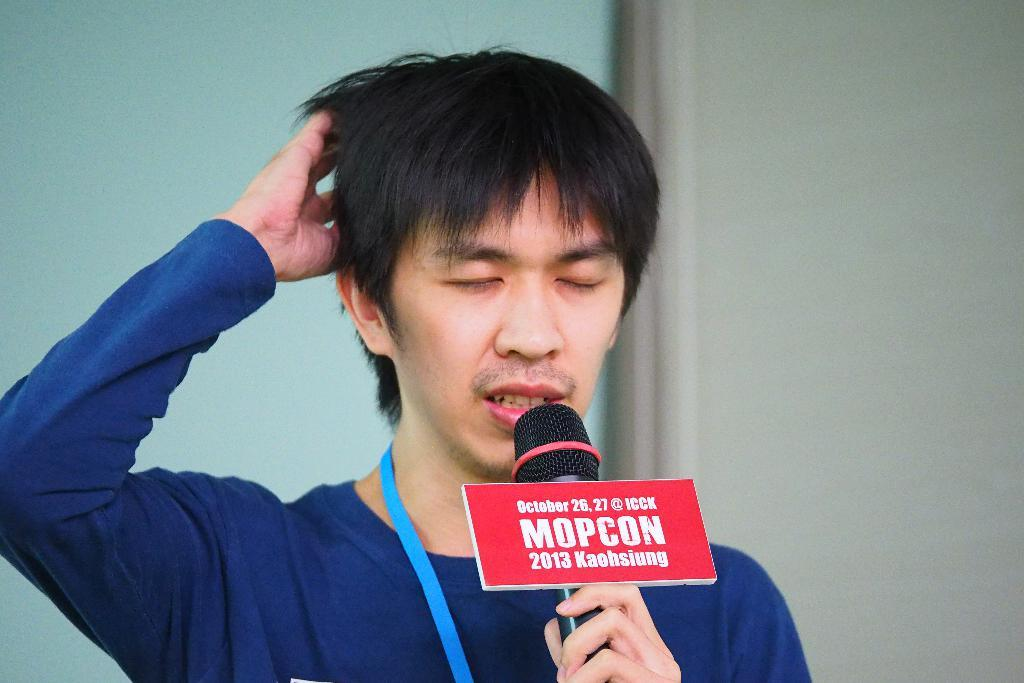What is the main subject of the image? There is a person in the image. What is the person holding in the image? The person is holding a microphone. Can you describe the object attached to the microphone? There is an aboard attached to the microphone with text on it. What can be seen in the background of the image? The background of the image is visible. What type of teeth can be seen growing on the seed in the image? There is no seed or teeth present in the image. What territory is being claimed by the person in the image? The image does not depict any territorial claims or disputes. 